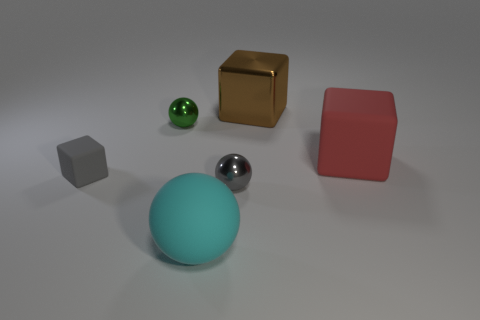Subtract all tiny shiny spheres. How many spheres are left? 1 Add 1 big things. How many objects exist? 7 Subtract 1 spheres. How many spheres are left? 2 Subtract all blue spheres. Subtract all cyan cylinders. How many spheres are left? 3 Subtract all blue cubes. How many gray balls are left? 1 Subtract all small red rubber cubes. Subtract all tiny blocks. How many objects are left? 5 Add 2 big matte cubes. How many big matte cubes are left? 3 Add 1 small red metallic things. How many small red metallic things exist? 1 Subtract all gray cubes. How many cubes are left? 2 Subtract 0 green blocks. How many objects are left? 6 